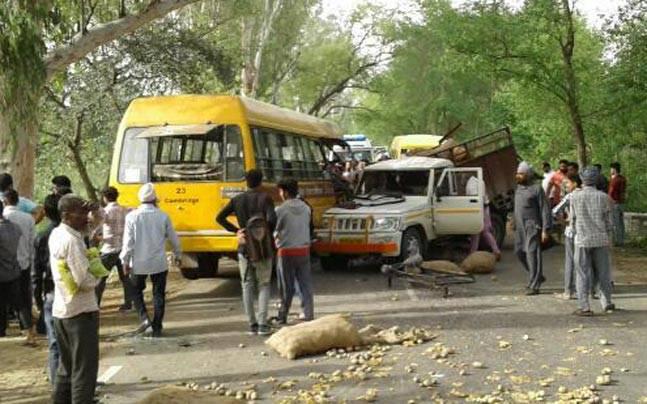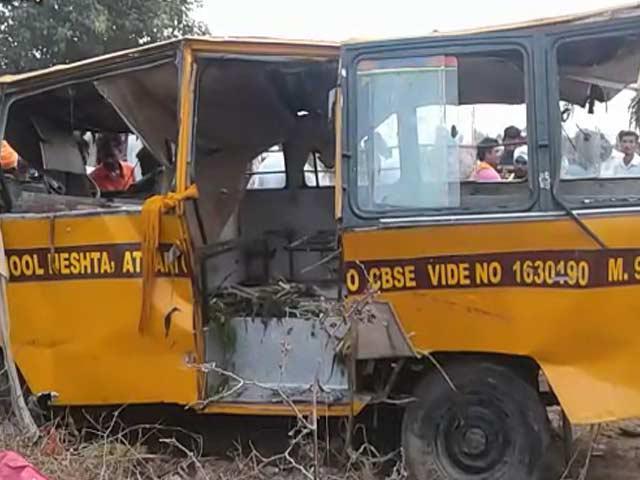The first image is the image on the left, the second image is the image on the right. Considering the images on both sides, is "At least one bus is not crashed." valid? Answer yes or no. No. 